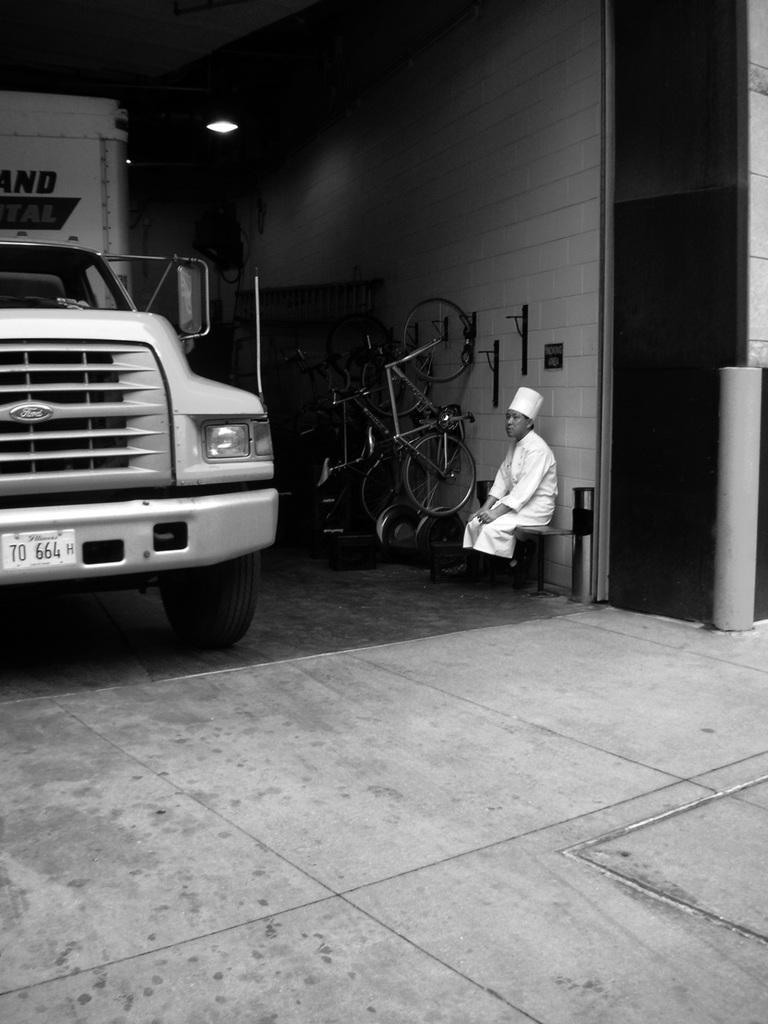Could you give a brief overview of what you see in this image? In the picture I can see a person wearing white dress is sitting and there are few bicycles beside him and there is a vehicle in front of him. 